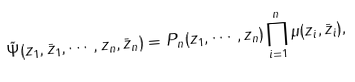<formula> <loc_0><loc_0><loc_500><loc_500>\tilde { \Psi } ( z _ { 1 } , \bar { z } _ { 1 } , \cdots , z _ { n } , \bar { z } _ { n } ) = P _ { n } ( z _ { 1 } , \cdots , z _ { n } ) \prod _ { i = 1 } ^ { n } \mu ( z _ { i } , \bar { z } _ { i } ) ,</formula> 